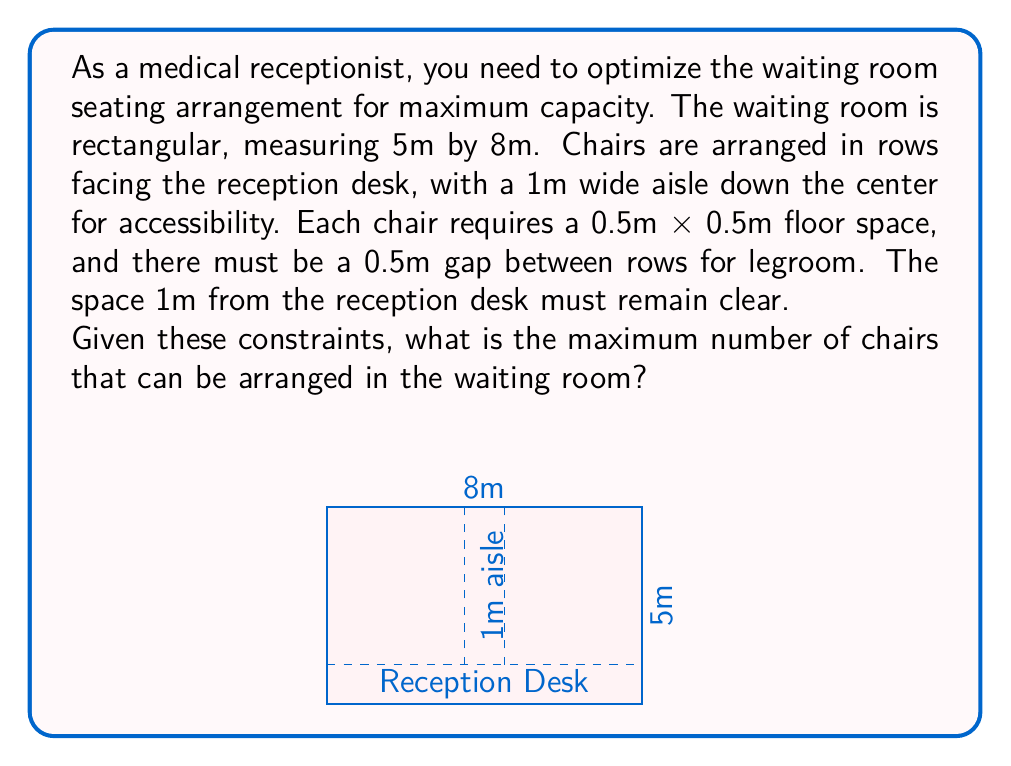Show me your answer to this math problem. Let's approach this step-by-step:

1) First, we need to calculate the usable area for seating:
   - Total area: $5m \times 8m = 40m^2$
   - Subtract the 1m area near the reception: $40m^2 - (1m \times 8m) = 32m^2$
   - Subtract the 1m wide center aisle: $32m^2 - (1m \times 4m) = 28m^2$

2) Now we have two identical areas for seating, each measuring $3.5m \times 4m$

3) For each seating area:
   - Width available for chairs: $3.5m$
   - Number of chairs per row: $\lfloor 3.5m \div 0.5m \rfloor = 7$ chairs

4) For the depth:
   - Total depth: $4m$
   - Each row takes $0.5m$ (chair) + $0.5m$ (legroom) $= 1m$
   - Number of rows: $\lfloor 4m \div 1m \rfloor = 4$ rows

5) Calculate chairs in one seating area:
   $7$ chairs/row $\times 4$ rows $= 28$ chairs

6) Total chairs in both seating areas:
   $28$ chairs $\times 2 = 56$ chairs

Therefore, the maximum number of chairs that can be arranged in the waiting room is 56.
Answer: 56 chairs 